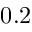<formula> <loc_0><loc_0><loc_500><loc_500>0 . 2</formula> 